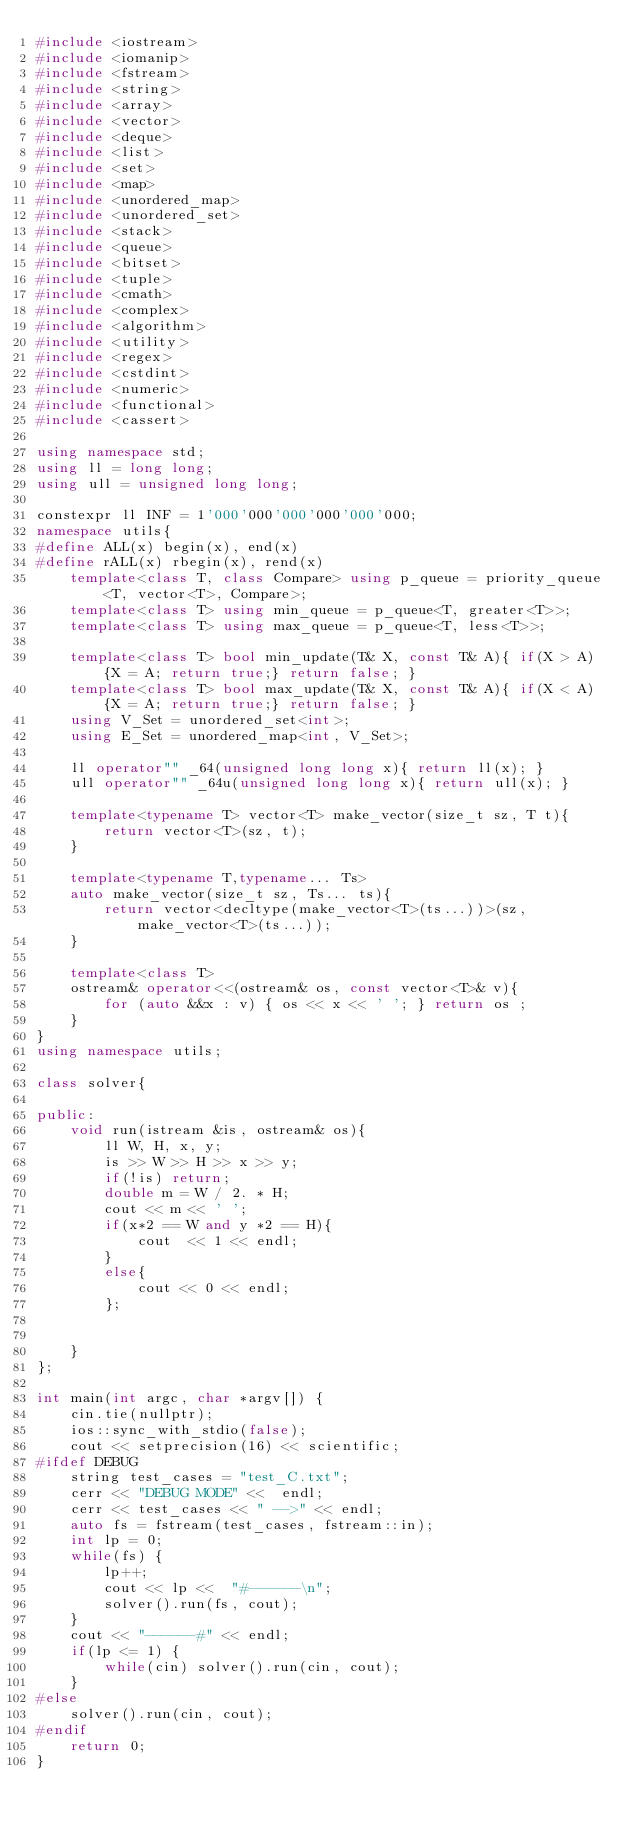<code> <loc_0><loc_0><loc_500><loc_500><_C++_>#include <iostream>
#include <iomanip>
#include <fstream>
#include <string>
#include <array>
#include <vector>
#include <deque>
#include <list>
#include <set>
#include <map>
#include <unordered_map>
#include <unordered_set>
#include <stack>
#include <queue>
#include <bitset>
#include <tuple>
#include <cmath>
#include <complex>
#include <algorithm>
#include <utility>
#include <regex>
#include <cstdint>
#include <numeric>
#include <functional>
#include <cassert>

using namespace std;
using ll = long long;
using ull = unsigned long long;

constexpr ll INF = 1'000'000'000'000'000'000;
namespace utils{
#define ALL(x) begin(x), end(x)
#define rALL(x) rbegin(x), rend(x)
    template<class T, class Compare> using p_queue = priority_queue<T, vector<T>, Compare>;
    template<class T> using min_queue = p_queue<T, greater<T>>;
    template<class T> using max_queue = p_queue<T, less<T>>;

    template<class T> bool min_update(T& X, const T& A){ if(X > A) {X = A; return true;} return false; }
    template<class T> bool max_update(T& X, const T& A){ if(X < A) {X = A; return true;} return false; }
    using V_Set = unordered_set<int>;
    using E_Set = unordered_map<int, V_Set>;

    ll operator"" _64(unsigned long long x){ return ll(x); }
    ull operator"" _64u(unsigned long long x){ return ull(x); }

    template<typename T> vector<T> make_vector(size_t sz, T t){
        return vector<T>(sz, t);
    }

    template<typename T,typename... Ts>
    auto make_vector(size_t sz, Ts... ts){
        return vector<decltype(make_vector<T>(ts...))>(sz, make_vector<T>(ts...));
    }

    template<class T>
    ostream& operator<<(ostream& os, const vector<T>& v){
        for (auto &&x : v) { os << x << ' '; } return os ;
    }
}
using namespace utils;

class solver{

public:
    void run(istream &is, ostream& os){
        ll W, H, x, y;
        is >> W >> H >> x >> y;
        if(!is) return;
        double m = W / 2. * H;
        cout << m << ' ';
        if(x*2 == W and y *2 == H){
            cout  << 1 << endl;
        }
        else{
            cout << 0 << endl;
        };


    }
};

int main(int argc, char *argv[]) {
    cin.tie(nullptr);
    ios::sync_with_stdio(false);
    cout << setprecision(16) << scientific;
#ifdef DEBUG
    string test_cases = "test_C.txt";
    cerr << "DEBUG MODE" <<  endl;
    cerr << test_cases << " -->" << endl;
    auto fs = fstream(test_cases, fstream::in);
    int lp = 0;
    while(fs) {
        lp++;
        cout << lp <<  "#------\n";
        solver().run(fs, cout);
    }
    cout << "------#" << endl;
    if(lp <= 1) {
        while(cin) solver().run(cin, cout);
    }
#else
    solver().run(cin, cout);
#endif
    return 0;
}
</code> 